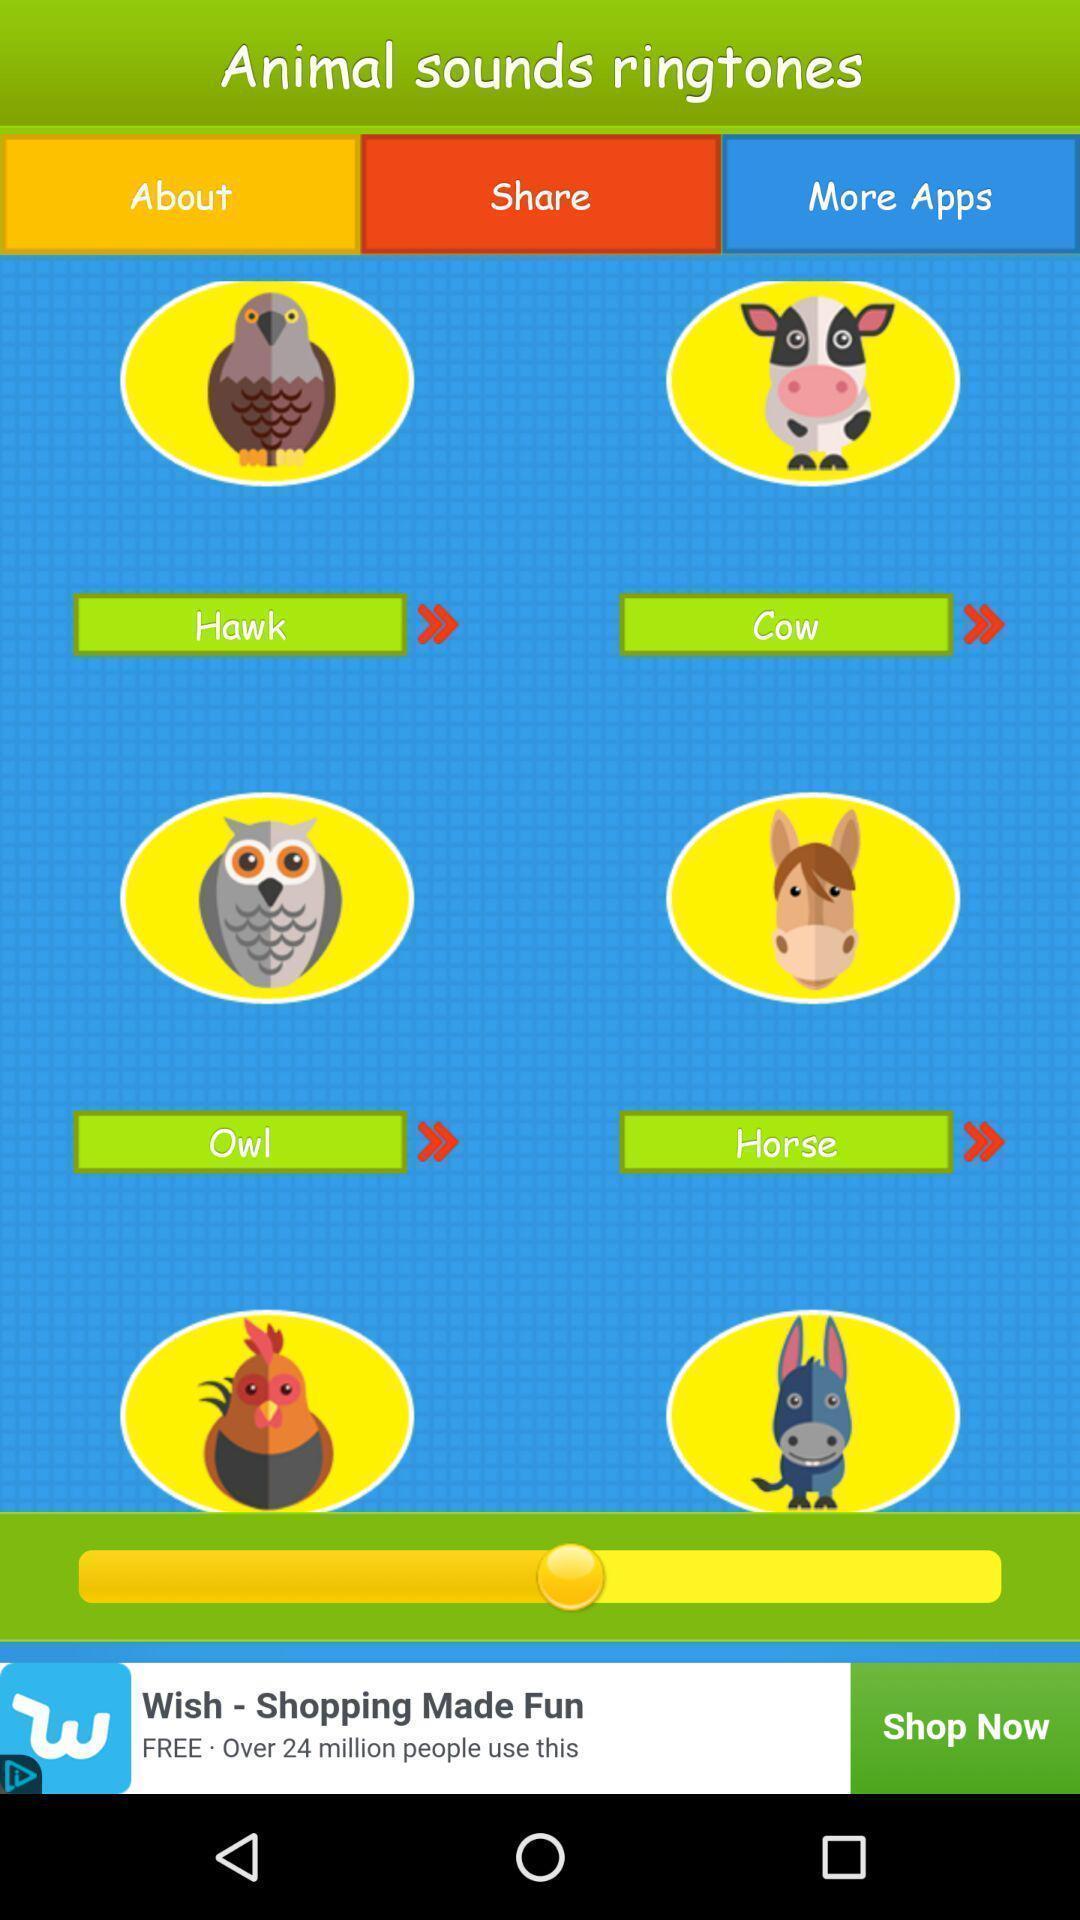Tell me about the visual elements in this screen capture. Various animated animal images displayed in a mimic sound app. 